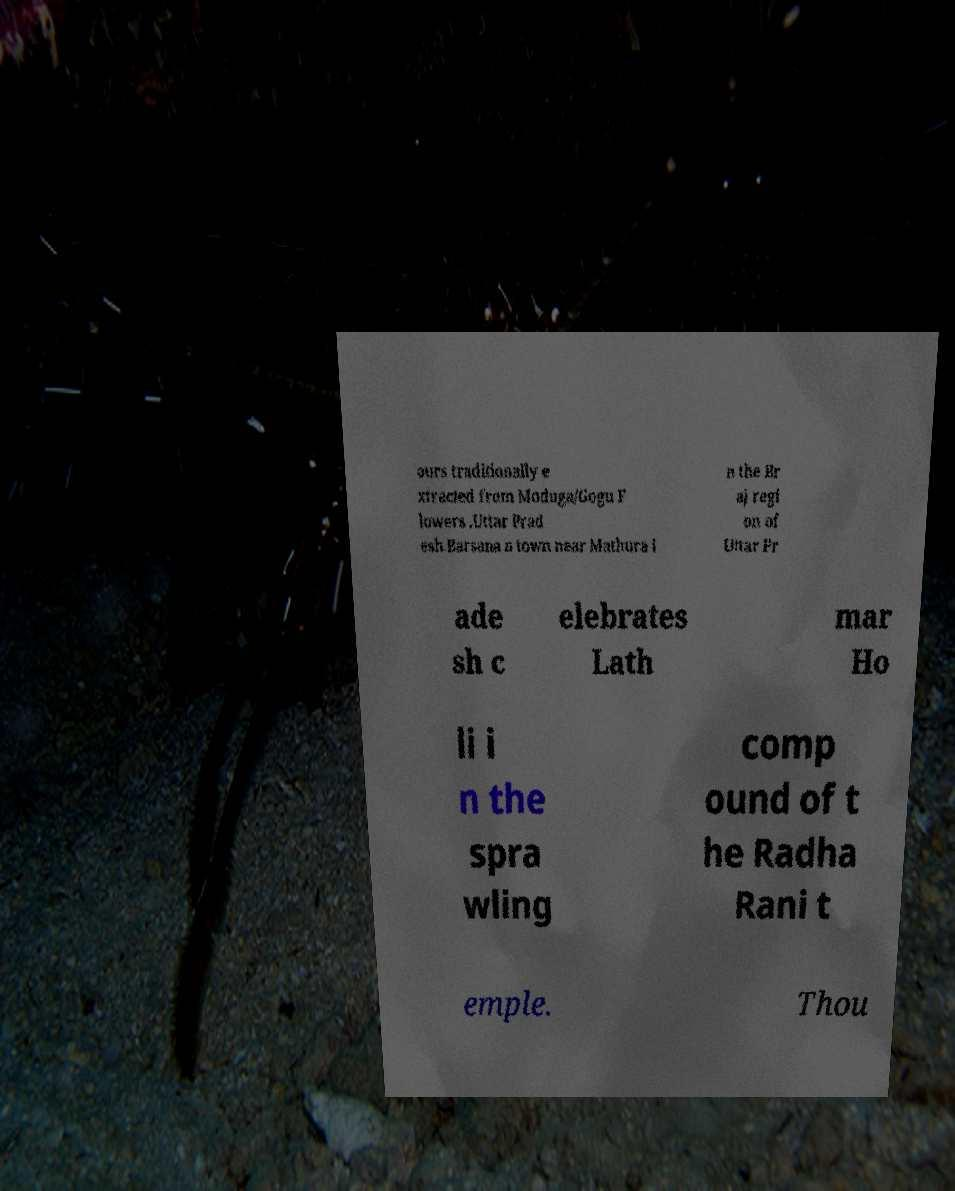Can you accurately transcribe the text from the provided image for me? ours traditionally e xtracted from Moduga/Gogu F lowers .Uttar Prad esh.Barsana a town near Mathura i n the Br aj regi on of Uttar Pr ade sh c elebrates Lath mar Ho li i n the spra wling comp ound of t he Radha Rani t emple. Thou 